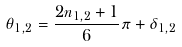Convert formula to latex. <formula><loc_0><loc_0><loc_500><loc_500>\theta _ { 1 , 2 } = \frac { 2 n _ { 1 , 2 } + 1 } { 6 } \pi + \delta _ { 1 , 2 }</formula> 